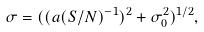<formula> <loc_0><loc_0><loc_500><loc_500>\sigma = ( ( a ( S / N ) ^ { - 1 } ) ^ { 2 } + \sigma _ { 0 } ^ { 2 } ) ^ { 1 / 2 } ,</formula> 